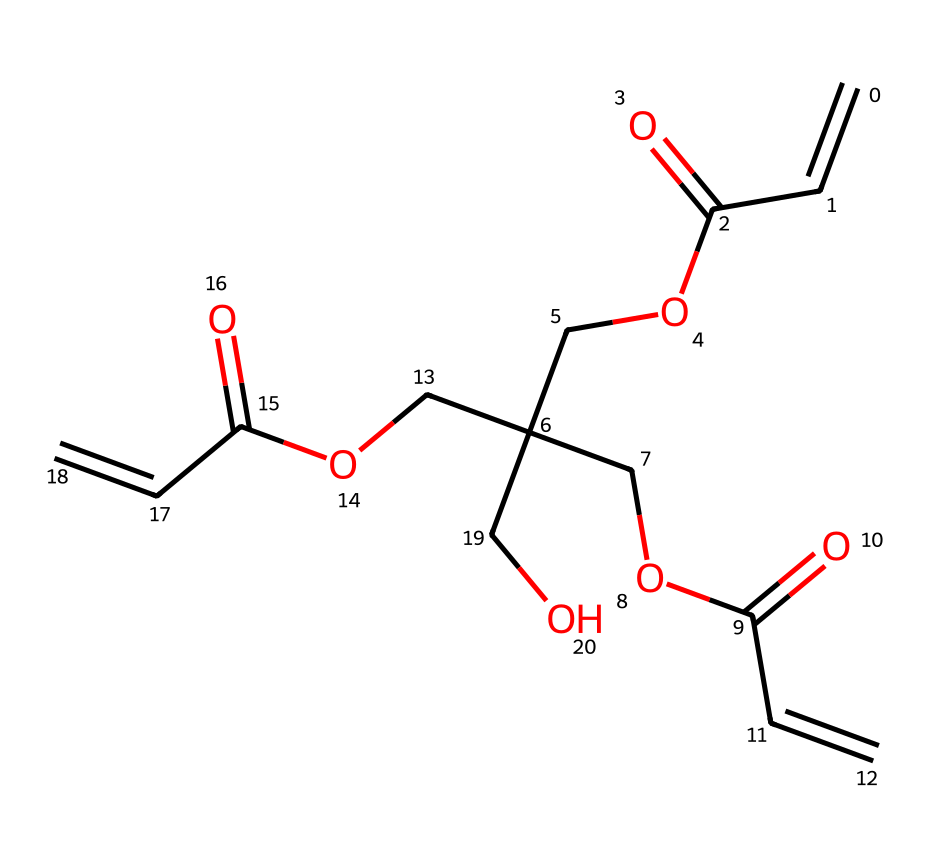What is the molecular formula of the compound represented by the SMILES? To find the molecular formula, we count the number of carbon (C), hydrogen (H), and oxygen (O) atoms in the SMILES representation. There are 15 carbon atoms, 22 hydrogen atoms, and 6 oxygen atoms. Thus, the molecular formula is C15H22O6.
Answer: C15H22O6 How many double bonds are present in the structure? In the SMILES notation, double bonds are represented by the '=' symbol. By analyzing the structure, we see there are two occurrences of the double bond (C=C). Therefore, there are 2 double bonds.
Answer: 2 What functional groups are present in this chemical? Looking at the structure, we identify carboxylic acid groups (due to C(=O)O), and ether groups (C-O-C). These functional groups are key indicators of the chemical's reactivity and properties as a crosslinking agent.
Answer: carboxylic acid and ether What type of polymerization does pentaerythritol triacrylate undergo? As a crosslinking agent with multiple acrylate groups, pentaerythritol triacrylate can undergo radical polymerization when exposed to UV light, which is typical in photoresist applications.
Answer: radical polymerization What is the role of pentaerythritol triacrylate in UV-curable photoresists? Pentaerythritol triacrylate acts as a crosslinking agent in UV-curable photoresists, helping to create a three-dimensional network upon exposure to UV light, which enhances the mechanical properties and resolution of the photoresist.
Answer: crosslinking agent How many ester linkages are present in the chemical structure? The ester functional group (RCOOR') appears where a carbonyl (C=O) is adjacent to an oxygen atom (O). In the given structure, we identify three ester linkages through the counts of (C(=O)O) connections, thus there are 3 ester linkages.
Answer: 3 